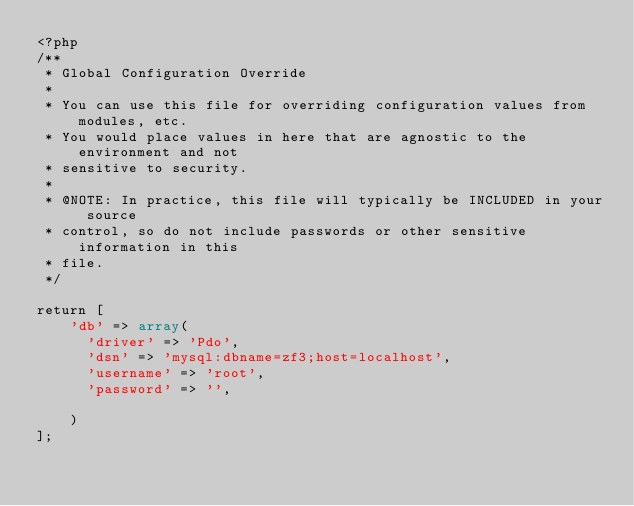Convert code to text. <code><loc_0><loc_0><loc_500><loc_500><_PHP_><?php
/**
 * Global Configuration Override
 *
 * You can use this file for overriding configuration values from modules, etc.
 * You would place values in here that are agnostic to the environment and not
 * sensitive to security.
 *
 * @NOTE: In practice, this file will typically be INCLUDED in your source
 * control, so do not include passwords or other sensitive information in this
 * file.
 */

return [
    'db' => array(
    	'driver' => 'Pdo',
    	'dsn' => 'mysql:dbname=zf3;host=localhost',
    	'username' => 'root',
    	'password' => '',

    )
];
</code> 